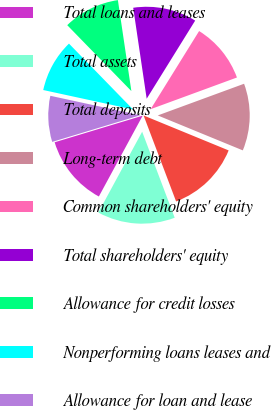<chart> <loc_0><loc_0><loc_500><loc_500><pie_chart><fcel>Total loans and leases<fcel>Total assets<fcel>Total deposits<fcel>Long-term debt<fcel>Common shareholders' equity<fcel>Total shareholders' equity<fcel>Allowance for credit losses<fcel>Nonperforming loans leases and<fcel>Allowance for loan and lease<nl><fcel>12.42%<fcel>13.66%<fcel>13.04%<fcel>11.8%<fcel>10.56%<fcel>11.18%<fcel>9.94%<fcel>9.32%<fcel>8.07%<nl></chart> 